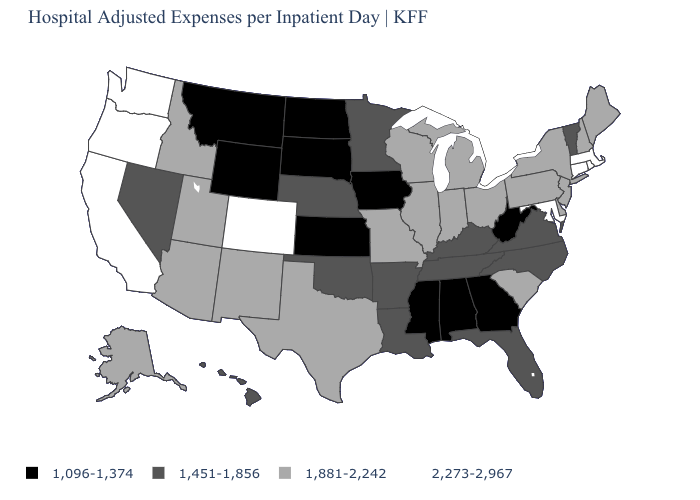What is the value of South Dakota?
Short answer required. 1,096-1,374. What is the value of Virginia?
Write a very short answer. 1,451-1,856. What is the highest value in the USA?
Keep it brief. 2,273-2,967. What is the value of North Carolina?
Short answer required. 1,451-1,856. Does the map have missing data?
Give a very brief answer. No. Does Illinois have a higher value than Nebraska?
Be succinct. Yes. Does the map have missing data?
Short answer required. No. Which states hav the highest value in the West?
Keep it brief. California, Colorado, Oregon, Washington. Name the states that have a value in the range 1,451-1,856?
Write a very short answer. Arkansas, Florida, Hawaii, Kentucky, Louisiana, Minnesota, Nebraska, Nevada, North Carolina, Oklahoma, Tennessee, Vermont, Virginia. What is the lowest value in the USA?
Give a very brief answer. 1,096-1,374. How many symbols are there in the legend?
Be succinct. 4. Name the states that have a value in the range 1,096-1,374?
Answer briefly. Alabama, Georgia, Iowa, Kansas, Mississippi, Montana, North Dakota, South Dakota, West Virginia, Wyoming. Among the states that border North Dakota , does Minnesota have the lowest value?
Write a very short answer. No. Does New Hampshire have a higher value than Indiana?
Write a very short answer. No. What is the value of New Mexico?
Keep it brief. 1,881-2,242. 